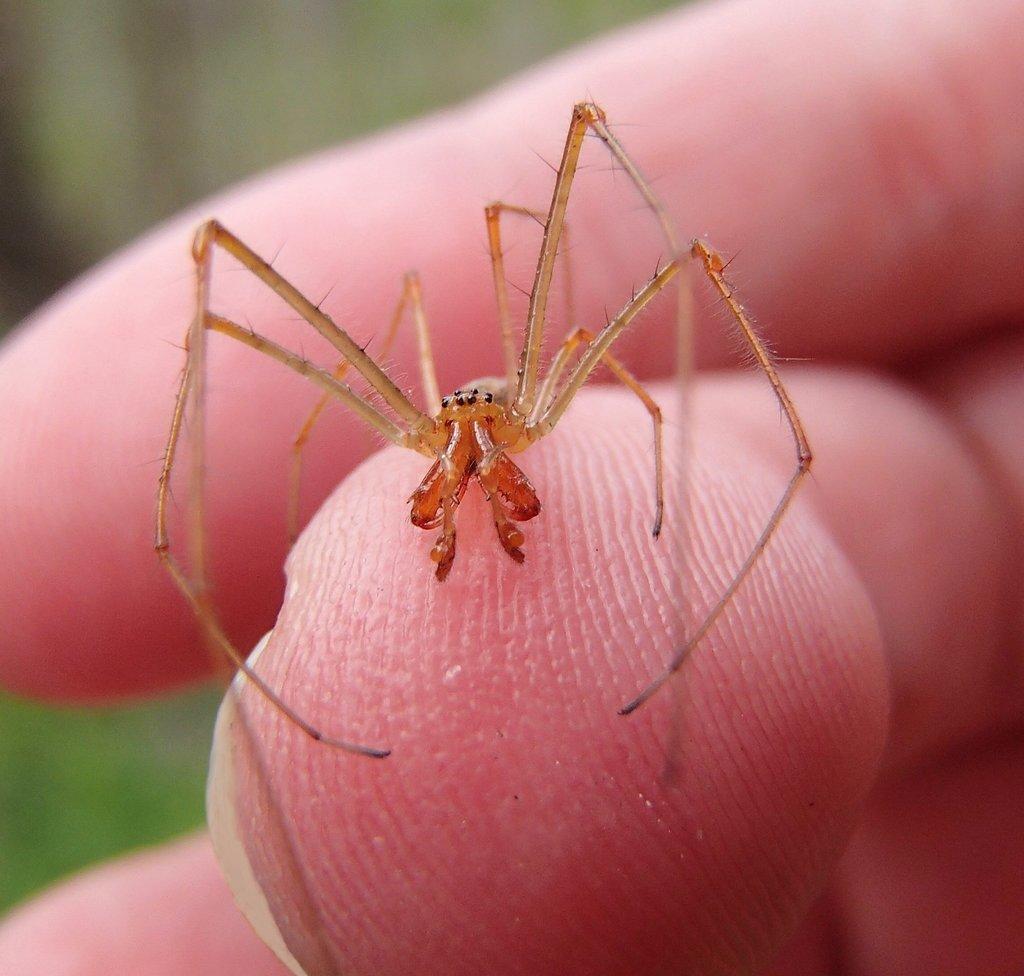Could you give a brief overview of what you see in this image? There is one spider on a finger of a person as we can see in the middle of this image. 